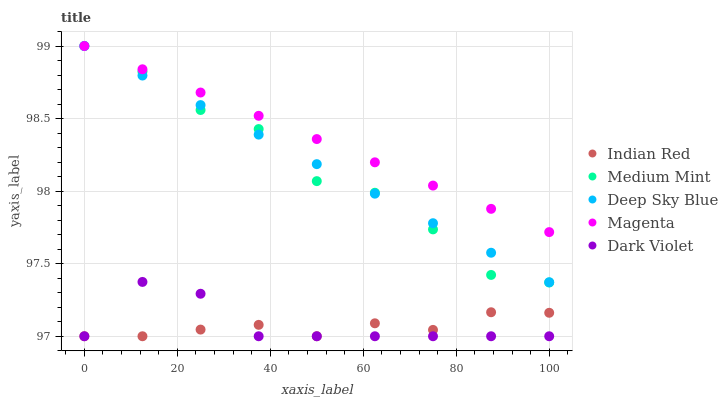Does Indian Red have the minimum area under the curve?
Answer yes or no. Yes. Does Magenta have the maximum area under the curve?
Answer yes or no. Yes. Does Dark Violet have the minimum area under the curve?
Answer yes or no. No. Does Dark Violet have the maximum area under the curve?
Answer yes or no. No. Is Deep Sky Blue the smoothest?
Answer yes or no. Yes. Is Medium Mint the roughest?
Answer yes or no. Yes. Is Magenta the smoothest?
Answer yes or no. No. Is Magenta the roughest?
Answer yes or no. No. Does Dark Violet have the lowest value?
Answer yes or no. Yes. Does Magenta have the lowest value?
Answer yes or no. No. Does Deep Sky Blue have the highest value?
Answer yes or no. Yes. Does Dark Violet have the highest value?
Answer yes or no. No. Is Dark Violet less than Medium Mint?
Answer yes or no. Yes. Is Magenta greater than Dark Violet?
Answer yes or no. Yes. Does Magenta intersect Medium Mint?
Answer yes or no. Yes. Is Magenta less than Medium Mint?
Answer yes or no. No. Is Magenta greater than Medium Mint?
Answer yes or no. No. Does Dark Violet intersect Medium Mint?
Answer yes or no. No. 